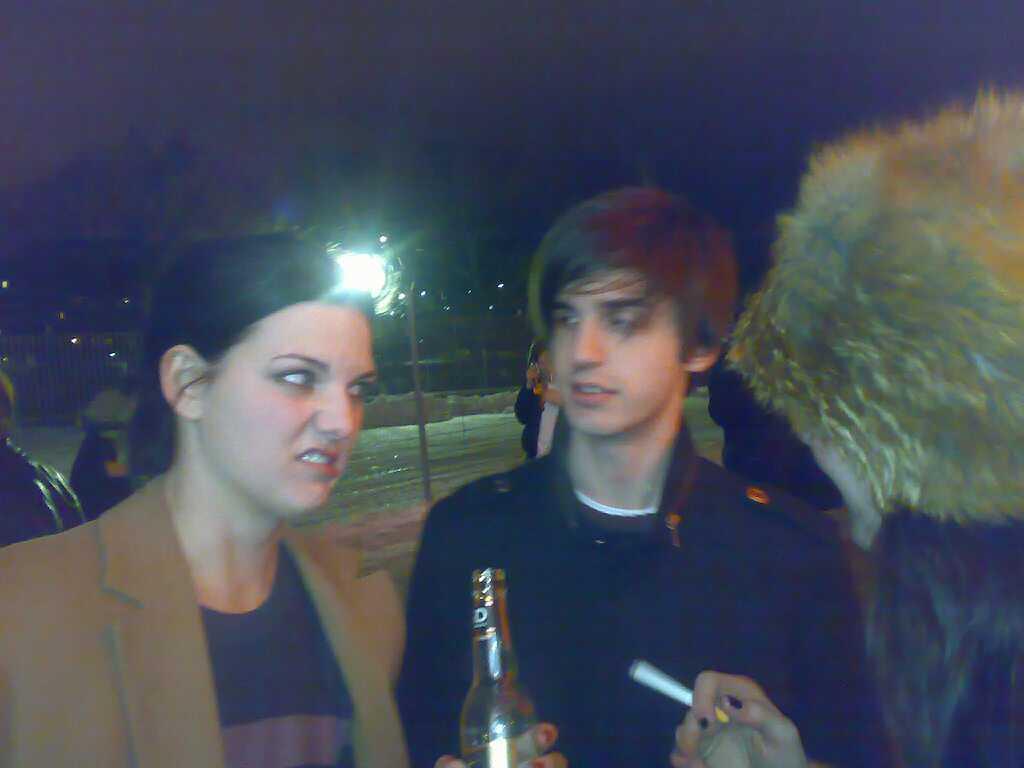Could you give a brief overview of what you see in this image? In the image we can see in front there are two people a woman and a man. A woman is holding a wine bottle and at the back there is a light on a street lamp. 